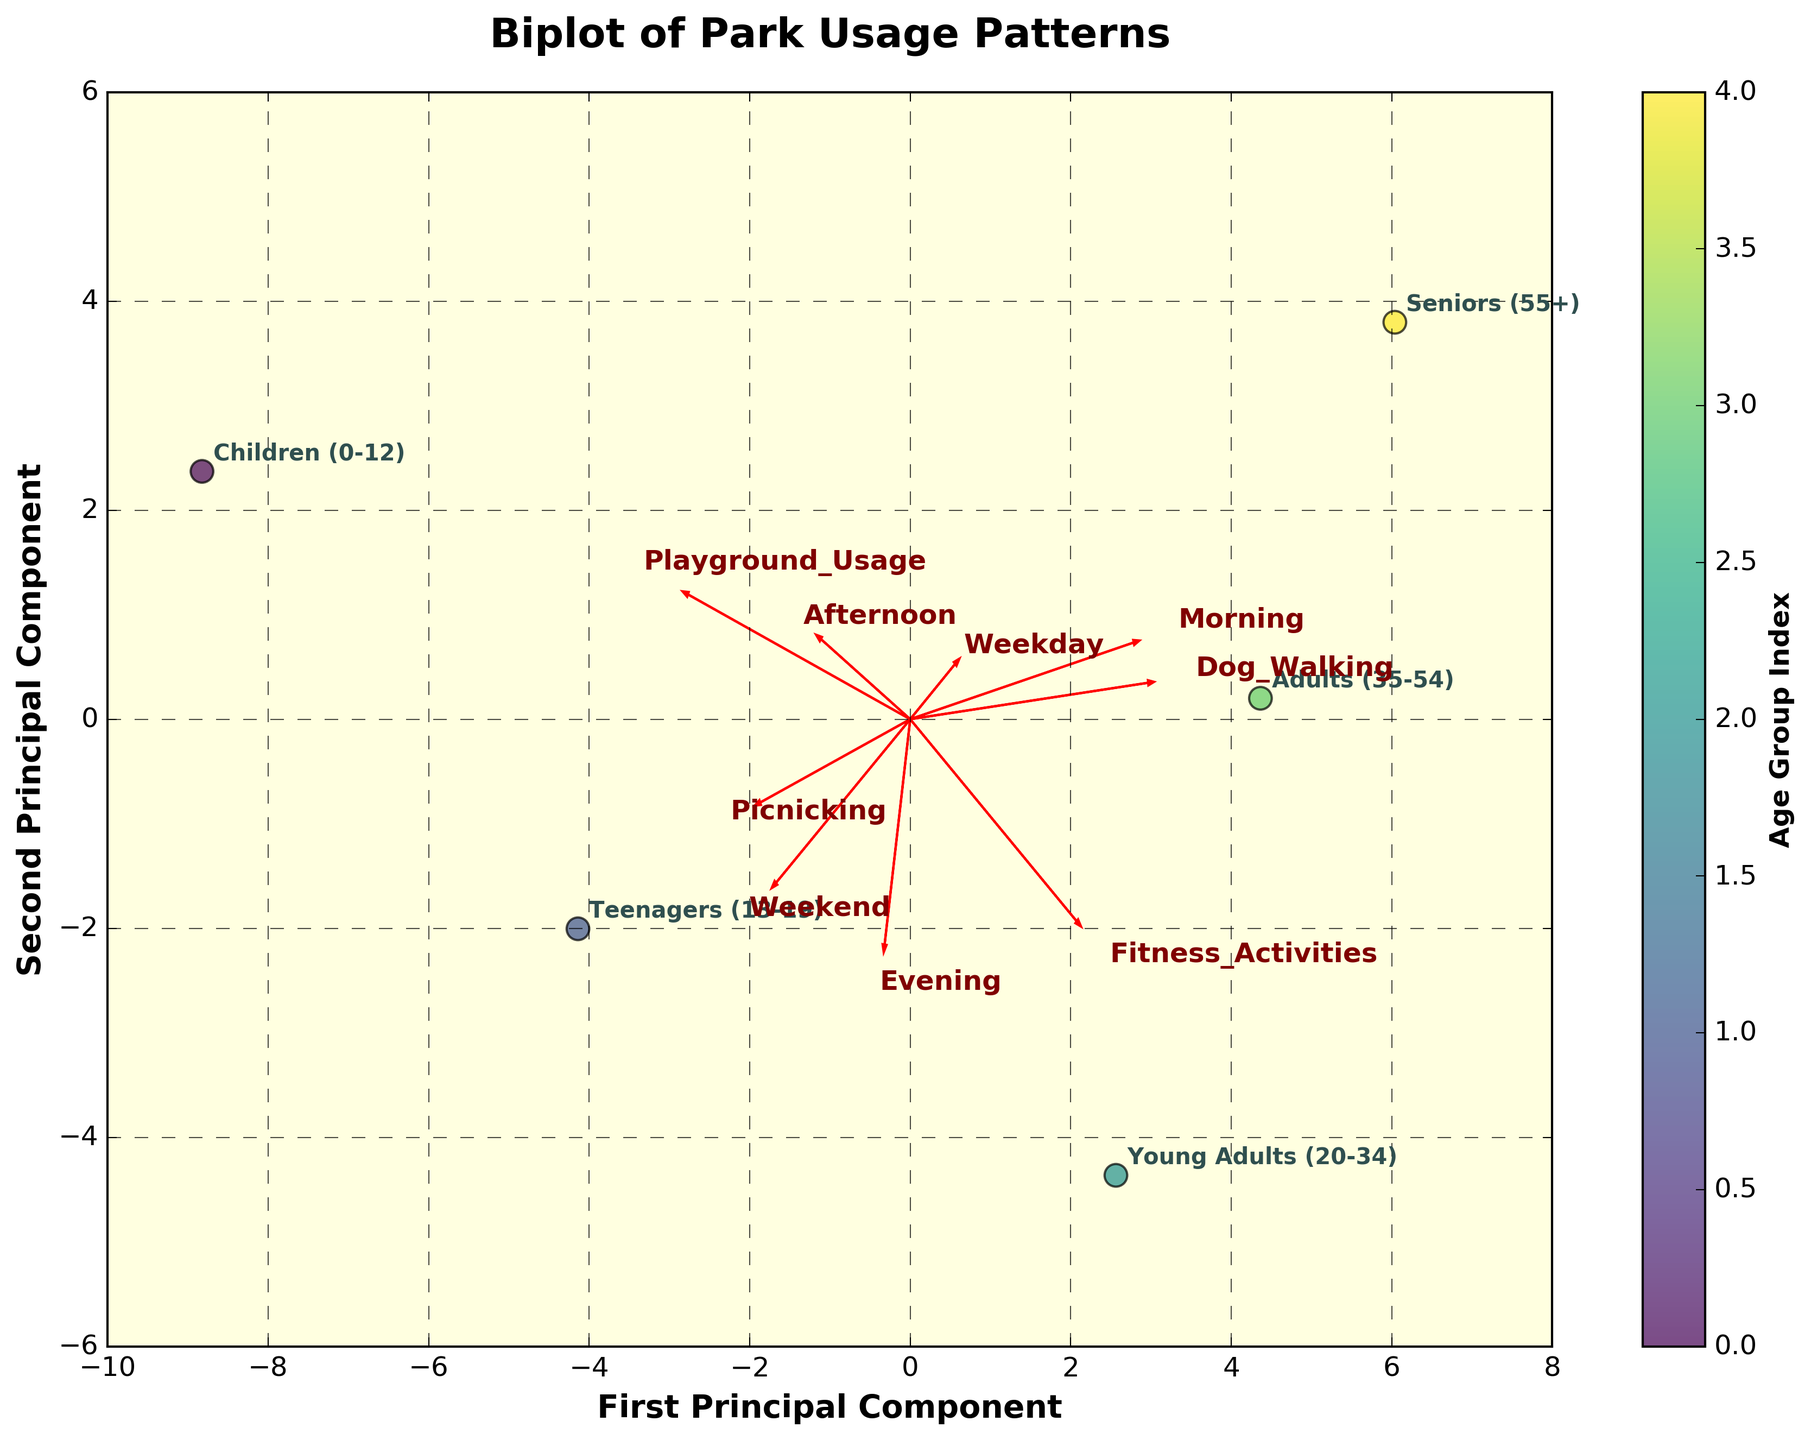What is the title of the biplot? The title of the biplot is displayed at the top of the figure.
Answer: Biplot of Park Usage Patterns How many age groups are represented in this biplot? Each age group is identified by a label next to each point in the plot. Count these labels.
Answer: 5 Which age group is most associated with "Morning"? Find the direction and length of the "Morning" arrow. The age group closest to the tip of this arrow is most associated with "Morning".
Answer: Seniors (55+) Which activity is least associated with the "Children (0-12)" age group? "Children (0-12)" is labeled near a point. Examine the end of each activity arrow and find which is farthest from this point.
Answer: Dog Walking Is "Fitness Activities" more associated with "Young Adults (20-34)" or "Adults (35-54)"? Compare the distances and directions of both age groups from the "Fitness Activities" arrow. The one closer to the arrow tip is more associated.
Answer: Young Adults (20-34) Which two age groups have the closest usage patterns based on the first two principal components? Identify which two age group points on the plot are closest to each other in terms of distance.
Answer: Teenagers (13-19) and Young Adults (20-34) What can you infer about the relationship between "Weekday" visits and "Weekend" visits among the age groups? Compare the direction and separation of the "Weekday" and "Weekend" arrows and their proximity to various age group points.
Answer: Most age groups have higher "Weekend" visits than "Weekday", as "Weekend" points toward more groups For what activity is "Seniors (55+)" the least associated according to this biplot? Look at the label for "Seniors (55+)" and find the activity arrow that points away from or is farthest from this label.
Answer: Playground Usage How would you describe the association of "Picnicking" with different age groups? See the direction and length of the "Picnicking" arrow and observe which age group points lie closest to it.
Answer: It is associated more with "Children (0-12)" and "Teenagers (13-19)", less with others Which principal component explains more variance in park usage patterns? Compare the spread of data points along the first and second principal components. Determine which axis has a wider spread of data points.
Answer: First Principal Component 